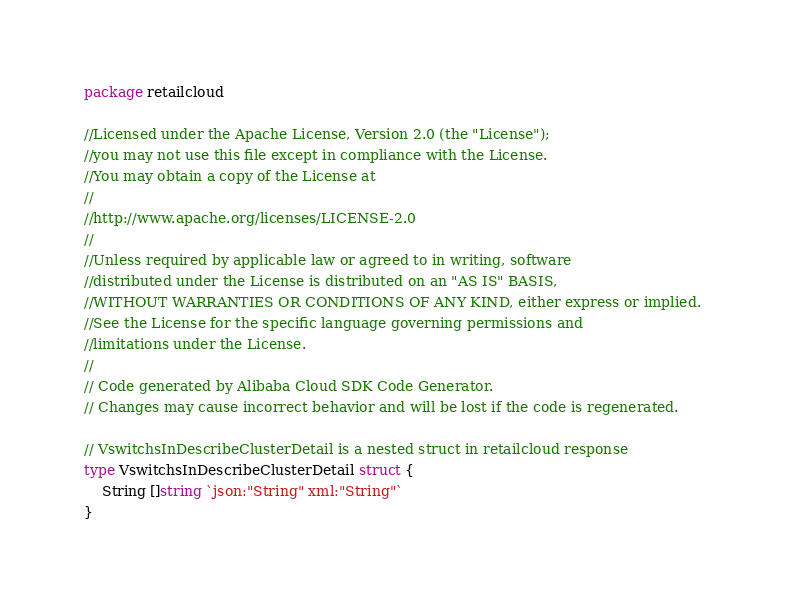Convert code to text. <code><loc_0><loc_0><loc_500><loc_500><_Go_>package retailcloud

//Licensed under the Apache License, Version 2.0 (the "License");
//you may not use this file except in compliance with the License.
//You may obtain a copy of the License at
//
//http://www.apache.org/licenses/LICENSE-2.0
//
//Unless required by applicable law or agreed to in writing, software
//distributed under the License is distributed on an "AS IS" BASIS,
//WITHOUT WARRANTIES OR CONDITIONS OF ANY KIND, either express or implied.
//See the License for the specific language governing permissions and
//limitations under the License.
//
// Code generated by Alibaba Cloud SDK Code Generator.
// Changes may cause incorrect behavior and will be lost if the code is regenerated.

// VswitchsInDescribeClusterDetail is a nested struct in retailcloud response
type VswitchsInDescribeClusterDetail struct {
	String []string `json:"String" xml:"String"`
}
</code> 